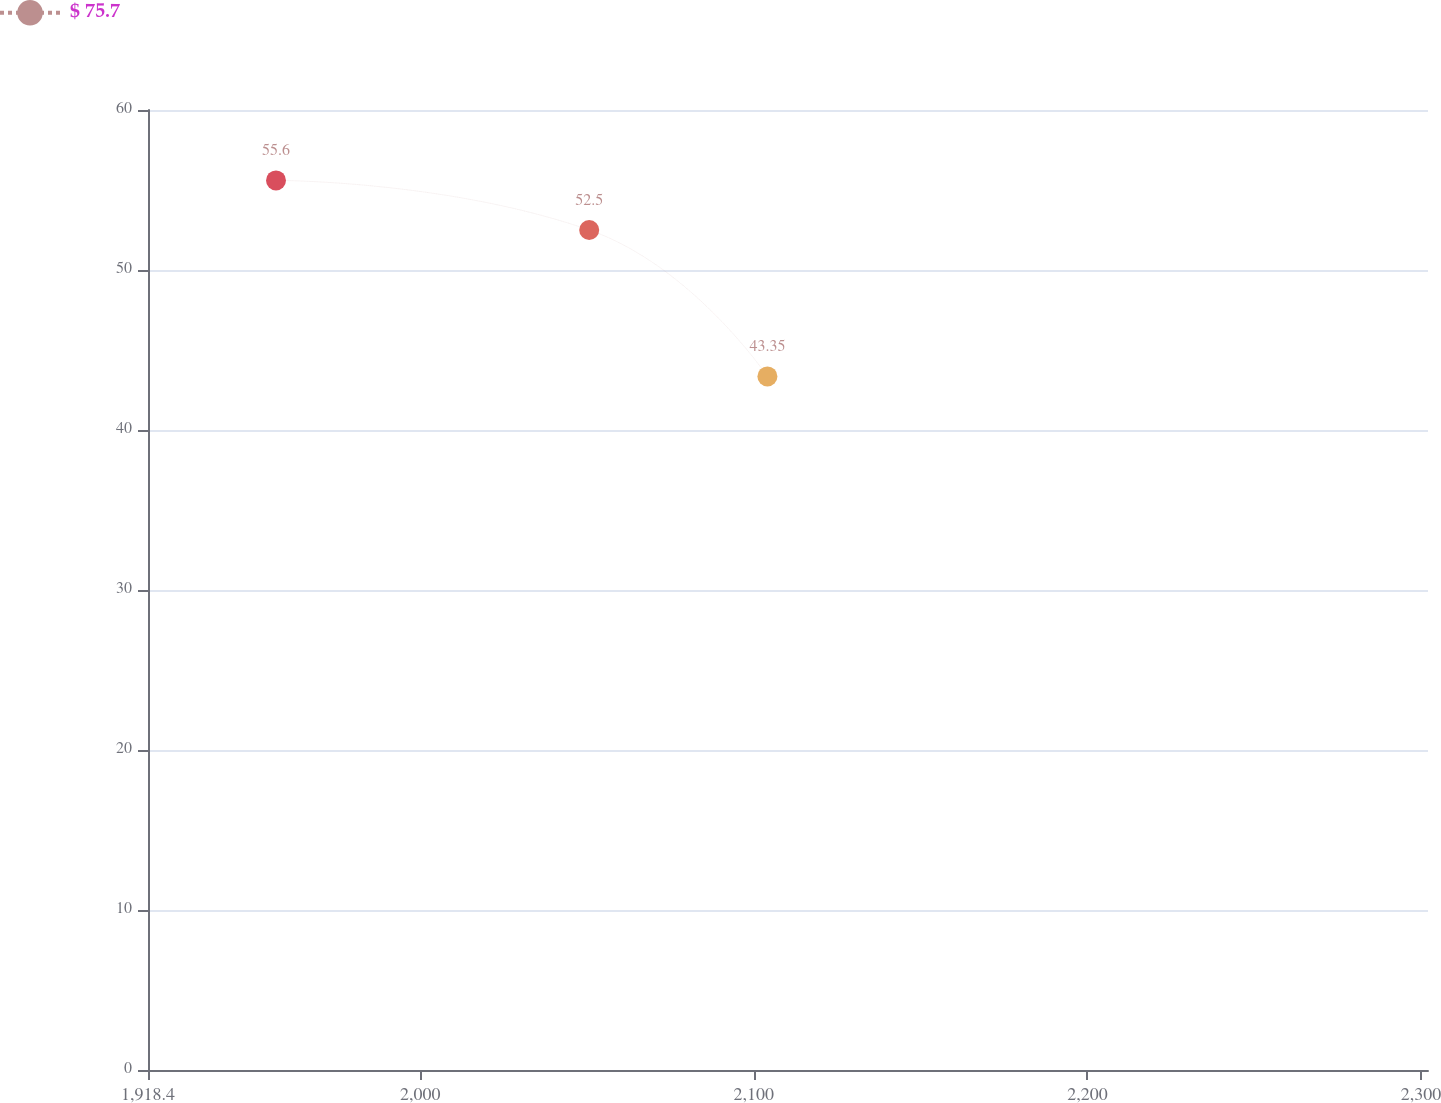Convert chart to OTSL. <chart><loc_0><loc_0><loc_500><loc_500><line_chart><ecel><fcel>$ 75.7<nl><fcel>1956.77<fcel>55.6<nl><fcel>2050.66<fcel>52.5<nl><fcel>2104.08<fcel>43.35<nl><fcel>2340.47<fcel>24.58<nl></chart> 